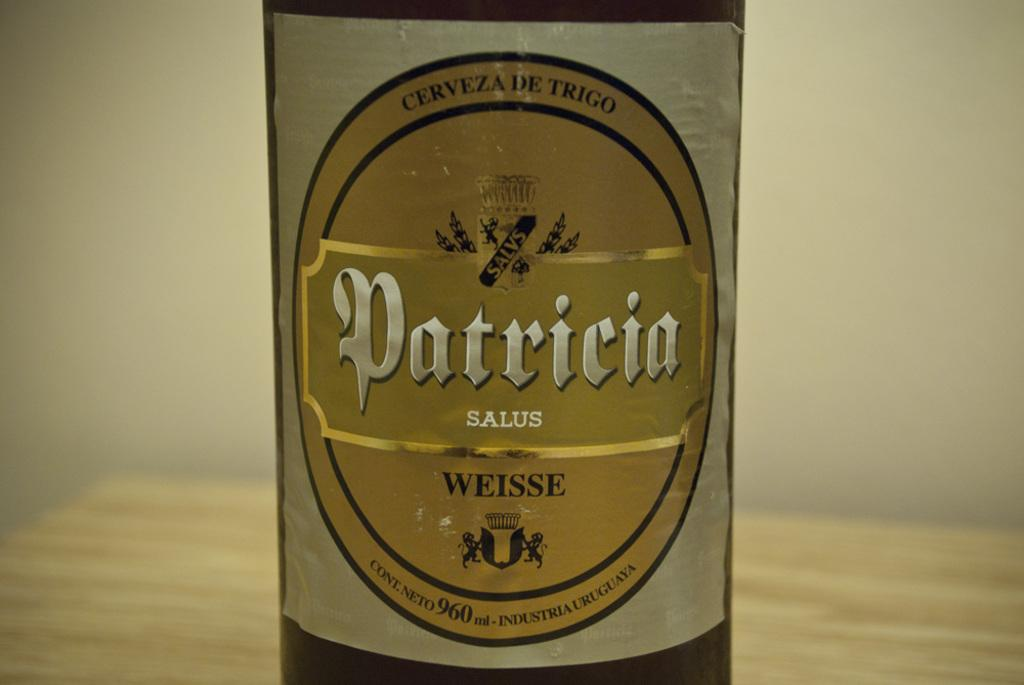<image>
Describe the image concisely. A bottle of Patricia cerveza de trigo sits on a wood surface. 